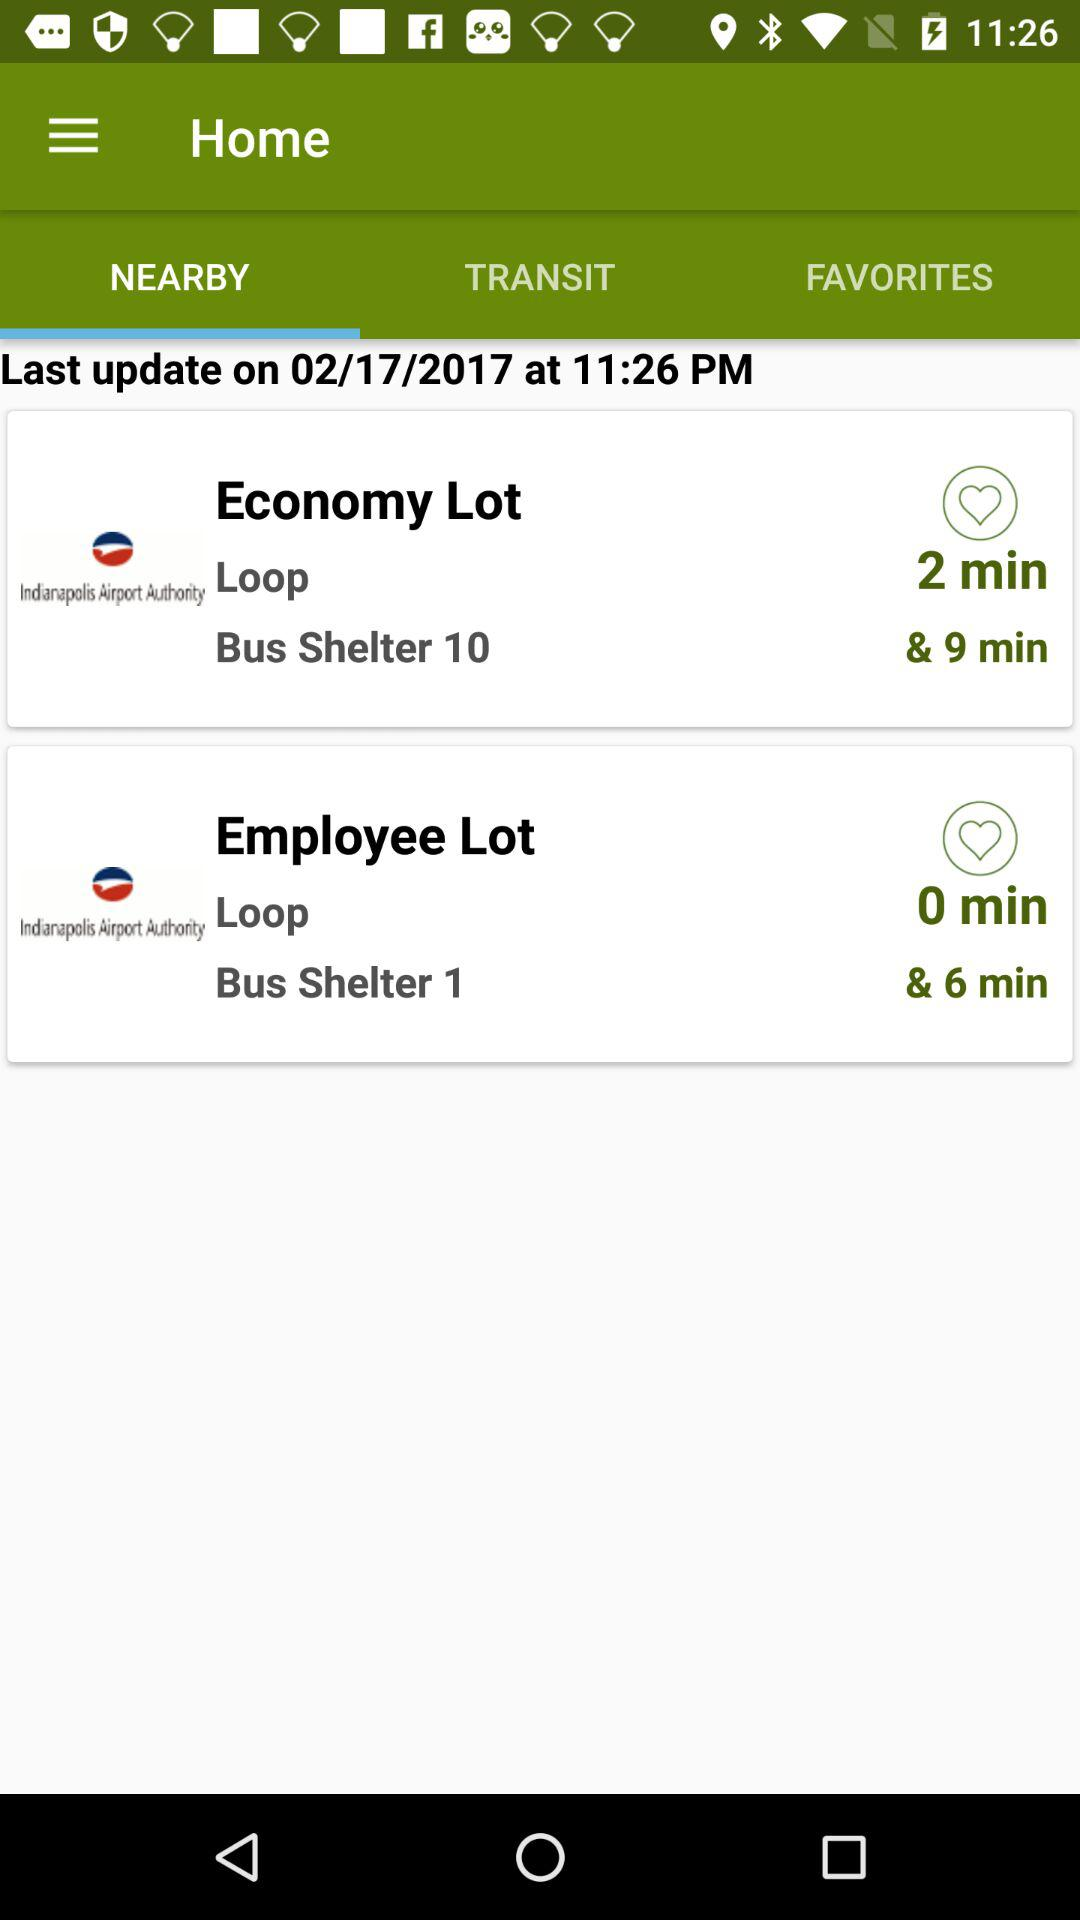Which bus shelter is there for the economy lot? For the economy lot, bus shelter 10 is there. 